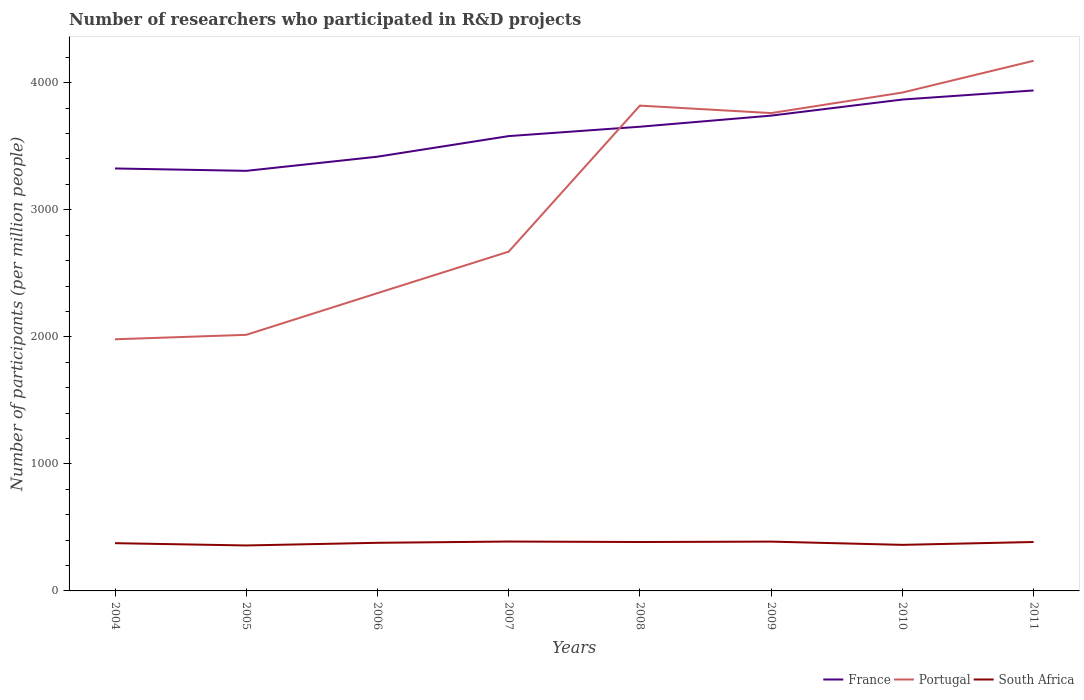Does the line corresponding to South Africa intersect with the line corresponding to France?
Make the answer very short. No. Is the number of lines equal to the number of legend labels?
Offer a terse response. Yes. Across all years, what is the maximum number of researchers who participated in R&D projects in South Africa?
Provide a succinct answer. 357.85. In which year was the number of researchers who participated in R&D projects in Portugal maximum?
Your response must be concise. 2004. What is the total number of researchers who participated in R&D projects in South Africa in the graph?
Provide a succinct answer. -9.97. What is the difference between the highest and the second highest number of researchers who participated in R&D projects in South Africa?
Your answer should be very brief. 30.94. What is the difference between the highest and the lowest number of researchers who participated in R&D projects in South Africa?
Provide a succinct answer. 5. How many lines are there?
Make the answer very short. 3. What is the difference between two consecutive major ticks on the Y-axis?
Offer a very short reply. 1000. Are the values on the major ticks of Y-axis written in scientific E-notation?
Provide a succinct answer. No. Does the graph contain any zero values?
Your answer should be very brief. No. Does the graph contain grids?
Your response must be concise. No. Where does the legend appear in the graph?
Make the answer very short. Bottom right. How are the legend labels stacked?
Ensure brevity in your answer.  Horizontal. What is the title of the graph?
Your response must be concise. Number of researchers who participated in R&D projects. What is the label or title of the X-axis?
Offer a terse response. Years. What is the label or title of the Y-axis?
Ensure brevity in your answer.  Number of participants (per million people). What is the Number of participants (per million people) in France in 2004?
Give a very brief answer. 3325.36. What is the Number of participants (per million people) of Portugal in 2004?
Offer a very short reply. 1980.77. What is the Number of participants (per million people) of South Africa in 2004?
Your answer should be compact. 375.83. What is the Number of participants (per million people) in France in 2005?
Provide a succinct answer. 3306.68. What is the Number of participants (per million people) of Portugal in 2005?
Provide a succinct answer. 2015.85. What is the Number of participants (per million people) in South Africa in 2005?
Make the answer very short. 357.85. What is the Number of participants (per million people) of France in 2006?
Ensure brevity in your answer.  3418.13. What is the Number of participants (per million people) of Portugal in 2006?
Your answer should be compact. 2344.02. What is the Number of participants (per million people) in South Africa in 2006?
Provide a short and direct response. 378.82. What is the Number of participants (per million people) of France in 2007?
Provide a succinct answer. 3580.19. What is the Number of participants (per million people) of Portugal in 2007?
Offer a terse response. 2670.52. What is the Number of participants (per million people) of South Africa in 2007?
Keep it short and to the point. 388.79. What is the Number of participants (per million people) of France in 2008?
Ensure brevity in your answer.  3653.99. What is the Number of participants (per million people) in Portugal in 2008?
Make the answer very short. 3820.2. What is the Number of participants (per million people) in South Africa in 2008?
Give a very brief answer. 385. What is the Number of participants (per million people) in France in 2009?
Provide a succinct answer. 3741.42. What is the Number of participants (per million people) in Portugal in 2009?
Provide a succinct answer. 3761.39. What is the Number of participants (per million people) in South Africa in 2009?
Offer a very short reply. 388.16. What is the Number of participants (per million people) in France in 2010?
Your answer should be compact. 3867.99. What is the Number of participants (per million people) of Portugal in 2010?
Your answer should be compact. 3922.91. What is the Number of participants (per million people) in South Africa in 2010?
Your response must be concise. 362.63. What is the Number of participants (per million people) in France in 2011?
Offer a very short reply. 3939.51. What is the Number of participants (per million people) of Portugal in 2011?
Keep it short and to the point. 4172.86. What is the Number of participants (per million people) of South Africa in 2011?
Offer a terse response. 385.07. Across all years, what is the maximum Number of participants (per million people) in France?
Keep it short and to the point. 3939.51. Across all years, what is the maximum Number of participants (per million people) of Portugal?
Your answer should be very brief. 4172.86. Across all years, what is the maximum Number of participants (per million people) in South Africa?
Make the answer very short. 388.79. Across all years, what is the minimum Number of participants (per million people) of France?
Offer a terse response. 3306.68. Across all years, what is the minimum Number of participants (per million people) of Portugal?
Give a very brief answer. 1980.77. Across all years, what is the minimum Number of participants (per million people) in South Africa?
Your answer should be very brief. 357.85. What is the total Number of participants (per million people) in France in the graph?
Make the answer very short. 2.88e+04. What is the total Number of participants (per million people) in Portugal in the graph?
Make the answer very short. 2.47e+04. What is the total Number of participants (per million people) of South Africa in the graph?
Provide a short and direct response. 3022.14. What is the difference between the Number of participants (per million people) of France in 2004 and that in 2005?
Your answer should be compact. 18.68. What is the difference between the Number of participants (per million people) of Portugal in 2004 and that in 2005?
Provide a short and direct response. -35.07. What is the difference between the Number of participants (per million people) of South Africa in 2004 and that in 2005?
Your answer should be compact. 17.98. What is the difference between the Number of participants (per million people) of France in 2004 and that in 2006?
Ensure brevity in your answer.  -92.77. What is the difference between the Number of participants (per million people) in Portugal in 2004 and that in 2006?
Keep it short and to the point. -363.25. What is the difference between the Number of participants (per million people) of South Africa in 2004 and that in 2006?
Provide a short and direct response. -3. What is the difference between the Number of participants (per million people) in France in 2004 and that in 2007?
Offer a very short reply. -254.83. What is the difference between the Number of participants (per million people) of Portugal in 2004 and that in 2007?
Make the answer very short. -689.75. What is the difference between the Number of participants (per million people) in South Africa in 2004 and that in 2007?
Your response must be concise. -12.96. What is the difference between the Number of participants (per million people) of France in 2004 and that in 2008?
Offer a very short reply. -328.63. What is the difference between the Number of participants (per million people) of Portugal in 2004 and that in 2008?
Provide a succinct answer. -1839.42. What is the difference between the Number of participants (per million people) in South Africa in 2004 and that in 2008?
Offer a very short reply. -9.18. What is the difference between the Number of participants (per million people) in France in 2004 and that in 2009?
Offer a terse response. -416.06. What is the difference between the Number of participants (per million people) of Portugal in 2004 and that in 2009?
Your answer should be compact. -1780.62. What is the difference between the Number of participants (per million people) of South Africa in 2004 and that in 2009?
Offer a very short reply. -12.33. What is the difference between the Number of participants (per million people) of France in 2004 and that in 2010?
Your answer should be very brief. -542.63. What is the difference between the Number of participants (per million people) in Portugal in 2004 and that in 2010?
Make the answer very short. -1942.14. What is the difference between the Number of participants (per million people) of South Africa in 2004 and that in 2010?
Make the answer very short. 13.19. What is the difference between the Number of participants (per million people) of France in 2004 and that in 2011?
Give a very brief answer. -614.15. What is the difference between the Number of participants (per million people) in Portugal in 2004 and that in 2011?
Give a very brief answer. -2192.09. What is the difference between the Number of participants (per million people) of South Africa in 2004 and that in 2011?
Give a very brief answer. -9.25. What is the difference between the Number of participants (per million people) in France in 2005 and that in 2006?
Keep it short and to the point. -111.45. What is the difference between the Number of participants (per million people) in Portugal in 2005 and that in 2006?
Your answer should be very brief. -328.18. What is the difference between the Number of participants (per million people) of South Africa in 2005 and that in 2006?
Keep it short and to the point. -20.97. What is the difference between the Number of participants (per million people) of France in 2005 and that in 2007?
Ensure brevity in your answer.  -273.51. What is the difference between the Number of participants (per million people) in Portugal in 2005 and that in 2007?
Provide a short and direct response. -654.68. What is the difference between the Number of participants (per million people) of South Africa in 2005 and that in 2007?
Give a very brief answer. -30.94. What is the difference between the Number of participants (per million people) of France in 2005 and that in 2008?
Provide a short and direct response. -347.31. What is the difference between the Number of participants (per million people) in Portugal in 2005 and that in 2008?
Make the answer very short. -1804.35. What is the difference between the Number of participants (per million people) of South Africa in 2005 and that in 2008?
Give a very brief answer. -27.15. What is the difference between the Number of participants (per million people) of France in 2005 and that in 2009?
Keep it short and to the point. -434.74. What is the difference between the Number of participants (per million people) of Portugal in 2005 and that in 2009?
Ensure brevity in your answer.  -1745.55. What is the difference between the Number of participants (per million people) in South Africa in 2005 and that in 2009?
Provide a succinct answer. -30.31. What is the difference between the Number of participants (per million people) in France in 2005 and that in 2010?
Ensure brevity in your answer.  -561.31. What is the difference between the Number of participants (per million people) of Portugal in 2005 and that in 2010?
Provide a succinct answer. -1907.07. What is the difference between the Number of participants (per million people) in South Africa in 2005 and that in 2010?
Make the answer very short. -4.78. What is the difference between the Number of participants (per million people) of France in 2005 and that in 2011?
Provide a succinct answer. -632.83. What is the difference between the Number of participants (per million people) of Portugal in 2005 and that in 2011?
Ensure brevity in your answer.  -2157.02. What is the difference between the Number of participants (per million people) in South Africa in 2005 and that in 2011?
Offer a very short reply. -27.22. What is the difference between the Number of participants (per million people) of France in 2006 and that in 2007?
Make the answer very short. -162.06. What is the difference between the Number of participants (per million people) of Portugal in 2006 and that in 2007?
Your response must be concise. -326.5. What is the difference between the Number of participants (per million people) in South Africa in 2006 and that in 2007?
Make the answer very short. -9.97. What is the difference between the Number of participants (per million people) of France in 2006 and that in 2008?
Provide a succinct answer. -235.86. What is the difference between the Number of participants (per million people) of Portugal in 2006 and that in 2008?
Ensure brevity in your answer.  -1476.17. What is the difference between the Number of participants (per million people) of South Africa in 2006 and that in 2008?
Give a very brief answer. -6.18. What is the difference between the Number of participants (per million people) in France in 2006 and that in 2009?
Your answer should be very brief. -323.29. What is the difference between the Number of participants (per million people) of Portugal in 2006 and that in 2009?
Ensure brevity in your answer.  -1417.37. What is the difference between the Number of participants (per million people) in South Africa in 2006 and that in 2009?
Your answer should be compact. -9.34. What is the difference between the Number of participants (per million people) of France in 2006 and that in 2010?
Make the answer very short. -449.86. What is the difference between the Number of participants (per million people) of Portugal in 2006 and that in 2010?
Your answer should be very brief. -1578.89. What is the difference between the Number of participants (per million people) in South Africa in 2006 and that in 2010?
Your answer should be very brief. 16.19. What is the difference between the Number of participants (per million people) of France in 2006 and that in 2011?
Offer a terse response. -521.38. What is the difference between the Number of participants (per million people) of Portugal in 2006 and that in 2011?
Offer a terse response. -1828.84. What is the difference between the Number of participants (per million people) in South Africa in 2006 and that in 2011?
Your answer should be compact. -6.25. What is the difference between the Number of participants (per million people) in France in 2007 and that in 2008?
Offer a very short reply. -73.8. What is the difference between the Number of participants (per million people) in Portugal in 2007 and that in 2008?
Offer a terse response. -1149.67. What is the difference between the Number of participants (per million people) of South Africa in 2007 and that in 2008?
Make the answer very short. 3.79. What is the difference between the Number of participants (per million people) of France in 2007 and that in 2009?
Make the answer very short. -161.23. What is the difference between the Number of participants (per million people) in Portugal in 2007 and that in 2009?
Ensure brevity in your answer.  -1090.87. What is the difference between the Number of participants (per million people) in South Africa in 2007 and that in 2009?
Give a very brief answer. 0.63. What is the difference between the Number of participants (per million people) in France in 2007 and that in 2010?
Your answer should be very brief. -287.8. What is the difference between the Number of participants (per million people) of Portugal in 2007 and that in 2010?
Keep it short and to the point. -1252.39. What is the difference between the Number of participants (per million people) of South Africa in 2007 and that in 2010?
Offer a very short reply. 26.16. What is the difference between the Number of participants (per million people) of France in 2007 and that in 2011?
Ensure brevity in your answer.  -359.32. What is the difference between the Number of participants (per million people) of Portugal in 2007 and that in 2011?
Your response must be concise. -1502.34. What is the difference between the Number of participants (per million people) of South Africa in 2007 and that in 2011?
Give a very brief answer. 3.72. What is the difference between the Number of participants (per million people) in France in 2008 and that in 2009?
Keep it short and to the point. -87.43. What is the difference between the Number of participants (per million people) in Portugal in 2008 and that in 2009?
Give a very brief answer. 58.8. What is the difference between the Number of participants (per million people) in South Africa in 2008 and that in 2009?
Make the answer very short. -3.16. What is the difference between the Number of participants (per million people) in France in 2008 and that in 2010?
Keep it short and to the point. -214. What is the difference between the Number of participants (per million people) of Portugal in 2008 and that in 2010?
Your response must be concise. -102.72. What is the difference between the Number of participants (per million people) in South Africa in 2008 and that in 2010?
Make the answer very short. 22.37. What is the difference between the Number of participants (per million people) of France in 2008 and that in 2011?
Your answer should be compact. -285.52. What is the difference between the Number of participants (per million people) of Portugal in 2008 and that in 2011?
Your answer should be very brief. -352.67. What is the difference between the Number of participants (per million people) in South Africa in 2008 and that in 2011?
Provide a succinct answer. -0.07. What is the difference between the Number of participants (per million people) of France in 2009 and that in 2010?
Provide a short and direct response. -126.57. What is the difference between the Number of participants (per million people) of Portugal in 2009 and that in 2010?
Your answer should be very brief. -161.52. What is the difference between the Number of participants (per million people) in South Africa in 2009 and that in 2010?
Offer a terse response. 25.53. What is the difference between the Number of participants (per million people) in France in 2009 and that in 2011?
Give a very brief answer. -198.09. What is the difference between the Number of participants (per million people) in Portugal in 2009 and that in 2011?
Offer a terse response. -411.47. What is the difference between the Number of participants (per million people) in South Africa in 2009 and that in 2011?
Provide a succinct answer. 3.09. What is the difference between the Number of participants (per million people) of France in 2010 and that in 2011?
Offer a terse response. -71.52. What is the difference between the Number of participants (per million people) in Portugal in 2010 and that in 2011?
Keep it short and to the point. -249.95. What is the difference between the Number of participants (per million people) in South Africa in 2010 and that in 2011?
Give a very brief answer. -22.44. What is the difference between the Number of participants (per million people) of France in 2004 and the Number of participants (per million people) of Portugal in 2005?
Provide a succinct answer. 1309.52. What is the difference between the Number of participants (per million people) in France in 2004 and the Number of participants (per million people) in South Africa in 2005?
Provide a short and direct response. 2967.52. What is the difference between the Number of participants (per million people) in Portugal in 2004 and the Number of participants (per million people) in South Africa in 2005?
Offer a very short reply. 1622.93. What is the difference between the Number of participants (per million people) in France in 2004 and the Number of participants (per million people) in Portugal in 2006?
Offer a terse response. 981.34. What is the difference between the Number of participants (per million people) of France in 2004 and the Number of participants (per million people) of South Africa in 2006?
Provide a succinct answer. 2946.54. What is the difference between the Number of participants (per million people) of Portugal in 2004 and the Number of participants (per million people) of South Africa in 2006?
Your answer should be very brief. 1601.95. What is the difference between the Number of participants (per million people) of France in 2004 and the Number of participants (per million people) of Portugal in 2007?
Keep it short and to the point. 654.84. What is the difference between the Number of participants (per million people) in France in 2004 and the Number of participants (per million people) in South Africa in 2007?
Provide a succinct answer. 2936.58. What is the difference between the Number of participants (per million people) of Portugal in 2004 and the Number of participants (per million people) of South Africa in 2007?
Make the answer very short. 1591.99. What is the difference between the Number of participants (per million people) of France in 2004 and the Number of participants (per million people) of Portugal in 2008?
Your answer should be very brief. -494.83. What is the difference between the Number of participants (per million people) in France in 2004 and the Number of participants (per million people) in South Africa in 2008?
Make the answer very short. 2940.36. What is the difference between the Number of participants (per million people) of Portugal in 2004 and the Number of participants (per million people) of South Africa in 2008?
Provide a short and direct response. 1595.77. What is the difference between the Number of participants (per million people) in France in 2004 and the Number of participants (per million people) in Portugal in 2009?
Keep it short and to the point. -436.03. What is the difference between the Number of participants (per million people) in France in 2004 and the Number of participants (per million people) in South Africa in 2009?
Keep it short and to the point. 2937.2. What is the difference between the Number of participants (per million people) of Portugal in 2004 and the Number of participants (per million people) of South Africa in 2009?
Offer a very short reply. 1592.61. What is the difference between the Number of participants (per million people) of France in 2004 and the Number of participants (per million people) of Portugal in 2010?
Provide a succinct answer. -597.55. What is the difference between the Number of participants (per million people) in France in 2004 and the Number of participants (per million people) in South Africa in 2010?
Provide a short and direct response. 2962.73. What is the difference between the Number of participants (per million people) of Portugal in 2004 and the Number of participants (per million people) of South Africa in 2010?
Make the answer very short. 1618.14. What is the difference between the Number of participants (per million people) in France in 2004 and the Number of participants (per million people) in Portugal in 2011?
Provide a short and direct response. -847.5. What is the difference between the Number of participants (per million people) in France in 2004 and the Number of participants (per million people) in South Africa in 2011?
Ensure brevity in your answer.  2940.29. What is the difference between the Number of participants (per million people) of Portugal in 2004 and the Number of participants (per million people) of South Africa in 2011?
Provide a short and direct response. 1595.7. What is the difference between the Number of participants (per million people) in France in 2005 and the Number of participants (per million people) in Portugal in 2006?
Offer a terse response. 962.66. What is the difference between the Number of participants (per million people) of France in 2005 and the Number of participants (per million people) of South Africa in 2006?
Your answer should be very brief. 2927.86. What is the difference between the Number of participants (per million people) of Portugal in 2005 and the Number of participants (per million people) of South Africa in 2006?
Offer a terse response. 1637.03. What is the difference between the Number of participants (per million people) of France in 2005 and the Number of participants (per million people) of Portugal in 2007?
Your response must be concise. 636.16. What is the difference between the Number of participants (per million people) of France in 2005 and the Number of participants (per million people) of South Africa in 2007?
Offer a very short reply. 2917.89. What is the difference between the Number of participants (per million people) of Portugal in 2005 and the Number of participants (per million people) of South Africa in 2007?
Offer a terse response. 1627.06. What is the difference between the Number of participants (per million people) in France in 2005 and the Number of participants (per million people) in Portugal in 2008?
Provide a succinct answer. -513.51. What is the difference between the Number of participants (per million people) of France in 2005 and the Number of participants (per million people) of South Africa in 2008?
Ensure brevity in your answer.  2921.68. What is the difference between the Number of participants (per million people) in Portugal in 2005 and the Number of participants (per million people) in South Africa in 2008?
Provide a short and direct response. 1630.85. What is the difference between the Number of participants (per million people) of France in 2005 and the Number of participants (per million people) of Portugal in 2009?
Give a very brief answer. -454.71. What is the difference between the Number of participants (per million people) in France in 2005 and the Number of participants (per million people) in South Africa in 2009?
Give a very brief answer. 2918.52. What is the difference between the Number of participants (per million people) in Portugal in 2005 and the Number of participants (per million people) in South Africa in 2009?
Make the answer very short. 1627.69. What is the difference between the Number of participants (per million people) of France in 2005 and the Number of participants (per million people) of Portugal in 2010?
Give a very brief answer. -616.23. What is the difference between the Number of participants (per million people) of France in 2005 and the Number of participants (per million people) of South Africa in 2010?
Keep it short and to the point. 2944.05. What is the difference between the Number of participants (per million people) of Portugal in 2005 and the Number of participants (per million people) of South Africa in 2010?
Your response must be concise. 1653.22. What is the difference between the Number of participants (per million people) of France in 2005 and the Number of participants (per million people) of Portugal in 2011?
Offer a terse response. -866.18. What is the difference between the Number of participants (per million people) in France in 2005 and the Number of participants (per million people) in South Africa in 2011?
Offer a terse response. 2921.61. What is the difference between the Number of participants (per million people) of Portugal in 2005 and the Number of participants (per million people) of South Africa in 2011?
Provide a succinct answer. 1630.78. What is the difference between the Number of participants (per million people) in France in 2006 and the Number of participants (per million people) in Portugal in 2007?
Keep it short and to the point. 747.61. What is the difference between the Number of participants (per million people) in France in 2006 and the Number of participants (per million people) in South Africa in 2007?
Make the answer very short. 3029.34. What is the difference between the Number of participants (per million people) of Portugal in 2006 and the Number of participants (per million people) of South Africa in 2007?
Make the answer very short. 1955.24. What is the difference between the Number of participants (per million people) in France in 2006 and the Number of participants (per million people) in Portugal in 2008?
Provide a short and direct response. -402.06. What is the difference between the Number of participants (per million people) in France in 2006 and the Number of participants (per million people) in South Africa in 2008?
Your answer should be compact. 3033.13. What is the difference between the Number of participants (per million people) of Portugal in 2006 and the Number of participants (per million people) of South Africa in 2008?
Offer a terse response. 1959.02. What is the difference between the Number of participants (per million people) in France in 2006 and the Number of participants (per million people) in Portugal in 2009?
Give a very brief answer. -343.26. What is the difference between the Number of participants (per million people) in France in 2006 and the Number of participants (per million people) in South Africa in 2009?
Your answer should be very brief. 3029.97. What is the difference between the Number of participants (per million people) of Portugal in 2006 and the Number of participants (per million people) of South Africa in 2009?
Ensure brevity in your answer.  1955.86. What is the difference between the Number of participants (per million people) in France in 2006 and the Number of participants (per million people) in Portugal in 2010?
Make the answer very short. -504.78. What is the difference between the Number of participants (per million people) of France in 2006 and the Number of participants (per million people) of South Africa in 2010?
Your response must be concise. 3055.5. What is the difference between the Number of participants (per million people) in Portugal in 2006 and the Number of participants (per million people) in South Africa in 2010?
Offer a terse response. 1981.39. What is the difference between the Number of participants (per million people) in France in 2006 and the Number of participants (per million people) in Portugal in 2011?
Your answer should be compact. -754.73. What is the difference between the Number of participants (per million people) of France in 2006 and the Number of participants (per million people) of South Africa in 2011?
Provide a short and direct response. 3033.06. What is the difference between the Number of participants (per million people) in Portugal in 2006 and the Number of participants (per million people) in South Africa in 2011?
Your response must be concise. 1958.95. What is the difference between the Number of participants (per million people) of France in 2007 and the Number of participants (per million people) of Portugal in 2008?
Your response must be concise. -240. What is the difference between the Number of participants (per million people) in France in 2007 and the Number of participants (per million people) in South Africa in 2008?
Offer a very short reply. 3195.19. What is the difference between the Number of participants (per million people) of Portugal in 2007 and the Number of participants (per million people) of South Africa in 2008?
Provide a short and direct response. 2285.52. What is the difference between the Number of participants (per million people) of France in 2007 and the Number of participants (per million people) of Portugal in 2009?
Provide a succinct answer. -181.2. What is the difference between the Number of participants (per million people) in France in 2007 and the Number of participants (per million people) in South Africa in 2009?
Provide a succinct answer. 3192.03. What is the difference between the Number of participants (per million people) in Portugal in 2007 and the Number of participants (per million people) in South Africa in 2009?
Offer a terse response. 2282.36. What is the difference between the Number of participants (per million people) of France in 2007 and the Number of participants (per million people) of Portugal in 2010?
Offer a terse response. -342.72. What is the difference between the Number of participants (per million people) in France in 2007 and the Number of participants (per million people) in South Africa in 2010?
Give a very brief answer. 3217.56. What is the difference between the Number of participants (per million people) in Portugal in 2007 and the Number of participants (per million people) in South Africa in 2010?
Keep it short and to the point. 2307.89. What is the difference between the Number of participants (per million people) in France in 2007 and the Number of participants (per million people) in Portugal in 2011?
Your answer should be compact. -592.67. What is the difference between the Number of participants (per million people) in France in 2007 and the Number of participants (per million people) in South Africa in 2011?
Your answer should be very brief. 3195.12. What is the difference between the Number of participants (per million people) of Portugal in 2007 and the Number of participants (per million people) of South Africa in 2011?
Give a very brief answer. 2285.45. What is the difference between the Number of participants (per million people) in France in 2008 and the Number of participants (per million people) in Portugal in 2009?
Offer a very short reply. -107.4. What is the difference between the Number of participants (per million people) of France in 2008 and the Number of participants (per million people) of South Africa in 2009?
Your response must be concise. 3265.83. What is the difference between the Number of participants (per million people) of Portugal in 2008 and the Number of participants (per million people) of South Africa in 2009?
Your response must be concise. 3432.04. What is the difference between the Number of participants (per million people) of France in 2008 and the Number of participants (per million people) of Portugal in 2010?
Your answer should be compact. -268.92. What is the difference between the Number of participants (per million people) in France in 2008 and the Number of participants (per million people) in South Africa in 2010?
Provide a succinct answer. 3291.36. What is the difference between the Number of participants (per million people) in Portugal in 2008 and the Number of participants (per million people) in South Africa in 2010?
Keep it short and to the point. 3457.56. What is the difference between the Number of participants (per million people) of France in 2008 and the Number of participants (per million people) of Portugal in 2011?
Ensure brevity in your answer.  -518.87. What is the difference between the Number of participants (per million people) in France in 2008 and the Number of participants (per million people) in South Africa in 2011?
Make the answer very short. 3268.92. What is the difference between the Number of participants (per million people) in Portugal in 2008 and the Number of participants (per million people) in South Africa in 2011?
Provide a succinct answer. 3435.12. What is the difference between the Number of participants (per million people) of France in 2009 and the Number of participants (per million people) of Portugal in 2010?
Provide a succinct answer. -181.49. What is the difference between the Number of participants (per million people) in France in 2009 and the Number of participants (per million people) in South Africa in 2010?
Make the answer very short. 3378.79. What is the difference between the Number of participants (per million people) in Portugal in 2009 and the Number of participants (per million people) in South Africa in 2010?
Your response must be concise. 3398.76. What is the difference between the Number of participants (per million people) of France in 2009 and the Number of participants (per million people) of Portugal in 2011?
Offer a terse response. -431.44. What is the difference between the Number of participants (per million people) in France in 2009 and the Number of participants (per million people) in South Africa in 2011?
Your answer should be compact. 3356.35. What is the difference between the Number of participants (per million people) in Portugal in 2009 and the Number of participants (per million people) in South Africa in 2011?
Your response must be concise. 3376.32. What is the difference between the Number of participants (per million people) in France in 2010 and the Number of participants (per million people) in Portugal in 2011?
Offer a terse response. -304.87. What is the difference between the Number of participants (per million people) of France in 2010 and the Number of participants (per million people) of South Africa in 2011?
Ensure brevity in your answer.  3482.92. What is the difference between the Number of participants (per million people) of Portugal in 2010 and the Number of participants (per million people) of South Africa in 2011?
Provide a short and direct response. 3537.84. What is the average Number of participants (per million people) in France per year?
Provide a succinct answer. 3604.16. What is the average Number of participants (per million people) in Portugal per year?
Make the answer very short. 3086.07. What is the average Number of participants (per million people) in South Africa per year?
Your answer should be compact. 377.77. In the year 2004, what is the difference between the Number of participants (per million people) in France and Number of participants (per million people) in Portugal?
Your answer should be compact. 1344.59. In the year 2004, what is the difference between the Number of participants (per million people) in France and Number of participants (per million people) in South Africa?
Provide a succinct answer. 2949.54. In the year 2004, what is the difference between the Number of participants (per million people) in Portugal and Number of participants (per million people) in South Africa?
Your answer should be compact. 1604.95. In the year 2005, what is the difference between the Number of participants (per million people) of France and Number of participants (per million people) of Portugal?
Keep it short and to the point. 1290.83. In the year 2005, what is the difference between the Number of participants (per million people) of France and Number of participants (per million people) of South Africa?
Give a very brief answer. 2948.83. In the year 2005, what is the difference between the Number of participants (per million people) in Portugal and Number of participants (per million people) in South Africa?
Your answer should be very brief. 1658. In the year 2006, what is the difference between the Number of participants (per million people) in France and Number of participants (per million people) in Portugal?
Provide a short and direct response. 1074.11. In the year 2006, what is the difference between the Number of participants (per million people) in France and Number of participants (per million people) in South Africa?
Your answer should be compact. 3039.31. In the year 2006, what is the difference between the Number of participants (per million people) in Portugal and Number of participants (per million people) in South Africa?
Provide a short and direct response. 1965.2. In the year 2007, what is the difference between the Number of participants (per million people) in France and Number of participants (per million people) in Portugal?
Provide a succinct answer. 909.67. In the year 2007, what is the difference between the Number of participants (per million people) in France and Number of participants (per million people) in South Africa?
Your answer should be very brief. 3191.41. In the year 2007, what is the difference between the Number of participants (per million people) in Portugal and Number of participants (per million people) in South Africa?
Offer a very short reply. 2281.74. In the year 2008, what is the difference between the Number of participants (per million people) in France and Number of participants (per million people) in Portugal?
Ensure brevity in your answer.  -166.2. In the year 2008, what is the difference between the Number of participants (per million people) of France and Number of participants (per million people) of South Africa?
Keep it short and to the point. 3268.99. In the year 2008, what is the difference between the Number of participants (per million people) in Portugal and Number of participants (per million people) in South Africa?
Provide a short and direct response. 3435.19. In the year 2009, what is the difference between the Number of participants (per million people) in France and Number of participants (per million people) in Portugal?
Provide a succinct answer. -19.97. In the year 2009, what is the difference between the Number of participants (per million people) of France and Number of participants (per million people) of South Africa?
Provide a short and direct response. 3353.26. In the year 2009, what is the difference between the Number of participants (per million people) of Portugal and Number of participants (per million people) of South Africa?
Offer a terse response. 3373.23. In the year 2010, what is the difference between the Number of participants (per million people) of France and Number of participants (per million people) of Portugal?
Your response must be concise. -54.92. In the year 2010, what is the difference between the Number of participants (per million people) in France and Number of participants (per million people) in South Africa?
Offer a terse response. 3505.36. In the year 2010, what is the difference between the Number of participants (per million people) of Portugal and Number of participants (per million people) of South Africa?
Keep it short and to the point. 3560.28. In the year 2011, what is the difference between the Number of participants (per million people) in France and Number of participants (per million people) in Portugal?
Make the answer very short. -233.35. In the year 2011, what is the difference between the Number of participants (per million people) of France and Number of participants (per million people) of South Africa?
Keep it short and to the point. 3554.44. In the year 2011, what is the difference between the Number of participants (per million people) in Portugal and Number of participants (per million people) in South Africa?
Ensure brevity in your answer.  3787.79. What is the ratio of the Number of participants (per million people) of France in 2004 to that in 2005?
Give a very brief answer. 1.01. What is the ratio of the Number of participants (per million people) of Portugal in 2004 to that in 2005?
Provide a short and direct response. 0.98. What is the ratio of the Number of participants (per million people) in South Africa in 2004 to that in 2005?
Keep it short and to the point. 1.05. What is the ratio of the Number of participants (per million people) of France in 2004 to that in 2006?
Your response must be concise. 0.97. What is the ratio of the Number of participants (per million people) of Portugal in 2004 to that in 2006?
Keep it short and to the point. 0.84. What is the ratio of the Number of participants (per million people) of South Africa in 2004 to that in 2006?
Give a very brief answer. 0.99. What is the ratio of the Number of participants (per million people) in France in 2004 to that in 2007?
Give a very brief answer. 0.93. What is the ratio of the Number of participants (per million people) in Portugal in 2004 to that in 2007?
Provide a short and direct response. 0.74. What is the ratio of the Number of participants (per million people) of South Africa in 2004 to that in 2007?
Make the answer very short. 0.97. What is the ratio of the Number of participants (per million people) of France in 2004 to that in 2008?
Make the answer very short. 0.91. What is the ratio of the Number of participants (per million people) of Portugal in 2004 to that in 2008?
Provide a short and direct response. 0.52. What is the ratio of the Number of participants (per million people) of South Africa in 2004 to that in 2008?
Provide a succinct answer. 0.98. What is the ratio of the Number of participants (per million people) in France in 2004 to that in 2009?
Your response must be concise. 0.89. What is the ratio of the Number of participants (per million people) in Portugal in 2004 to that in 2009?
Your response must be concise. 0.53. What is the ratio of the Number of participants (per million people) in South Africa in 2004 to that in 2009?
Keep it short and to the point. 0.97. What is the ratio of the Number of participants (per million people) in France in 2004 to that in 2010?
Provide a short and direct response. 0.86. What is the ratio of the Number of participants (per million people) in Portugal in 2004 to that in 2010?
Your answer should be very brief. 0.5. What is the ratio of the Number of participants (per million people) in South Africa in 2004 to that in 2010?
Ensure brevity in your answer.  1.04. What is the ratio of the Number of participants (per million people) of France in 2004 to that in 2011?
Provide a short and direct response. 0.84. What is the ratio of the Number of participants (per million people) of Portugal in 2004 to that in 2011?
Your answer should be very brief. 0.47. What is the ratio of the Number of participants (per million people) in France in 2005 to that in 2006?
Offer a very short reply. 0.97. What is the ratio of the Number of participants (per million people) in Portugal in 2005 to that in 2006?
Your answer should be very brief. 0.86. What is the ratio of the Number of participants (per million people) in South Africa in 2005 to that in 2006?
Ensure brevity in your answer.  0.94. What is the ratio of the Number of participants (per million people) of France in 2005 to that in 2007?
Ensure brevity in your answer.  0.92. What is the ratio of the Number of participants (per million people) in Portugal in 2005 to that in 2007?
Your response must be concise. 0.75. What is the ratio of the Number of participants (per million people) in South Africa in 2005 to that in 2007?
Offer a terse response. 0.92. What is the ratio of the Number of participants (per million people) in France in 2005 to that in 2008?
Your answer should be compact. 0.91. What is the ratio of the Number of participants (per million people) in Portugal in 2005 to that in 2008?
Provide a succinct answer. 0.53. What is the ratio of the Number of participants (per million people) of South Africa in 2005 to that in 2008?
Your answer should be compact. 0.93. What is the ratio of the Number of participants (per million people) of France in 2005 to that in 2009?
Make the answer very short. 0.88. What is the ratio of the Number of participants (per million people) in Portugal in 2005 to that in 2009?
Offer a very short reply. 0.54. What is the ratio of the Number of participants (per million people) of South Africa in 2005 to that in 2009?
Your answer should be compact. 0.92. What is the ratio of the Number of participants (per million people) in France in 2005 to that in 2010?
Your answer should be very brief. 0.85. What is the ratio of the Number of participants (per million people) in Portugal in 2005 to that in 2010?
Provide a succinct answer. 0.51. What is the ratio of the Number of participants (per million people) in South Africa in 2005 to that in 2010?
Your answer should be compact. 0.99. What is the ratio of the Number of participants (per million people) in France in 2005 to that in 2011?
Give a very brief answer. 0.84. What is the ratio of the Number of participants (per million people) in Portugal in 2005 to that in 2011?
Offer a terse response. 0.48. What is the ratio of the Number of participants (per million people) in South Africa in 2005 to that in 2011?
Provide a short and direct response. 0.93. What is the ratio of the Number of participants (per million people) of France in 2006 to that in 2007?
Provide a short and direct response. 0.95. What is the ratio of the Number of participants (per million people) of Portugal in 2006 to that in 2007?
Provide a succinct answer. 0.88. What is the ratio of the Number of participants (per million people) in South Africa in 2006 to that in 2007?
Give a very brief answer. 0.97. What is the ratio of the Number of participants (per million people) in France in 2006 to that in 2008?
Offer a very short reply. 0.94. What is the ratio of the Number of participants (per million people) in Portugal in 2006 to that in 2008?
Your answer should be compact. 0.61. What is the ratio of the Number of participants (per million people) of South Africa in 2006 to that in 2008?
Provide a succinct answer. 0.98. What is the ratio of the Number of participants (per million people) of France in 2006 to that in 2009?
Ensure brevity in your answer.  0.91. What is the ratio of the Number of participants (per million people) of Portugal in 2006 to that in 2009?
Keep it short and to the point. 0.62. What is the ratio of the Number of participants (per million people) in South Africa in 2006 to that in 2009?
Your response must be concise. 0.98. What is the ratio of the Number of participants (per million people) of France in 2006 to that in 2010?
Your answer should be very brief. 0.88. What is the ratio of the Number of participants (per million people) in Portugal in 2006 to that in 2010?
Give a very brief answer. 0.6. What is the ratio of the Number of participants (per million people) in South Africa in 2006 to that in 2010?
Make the answer very short. 1.04. What is the ratio of the Number of participants (per million people) of France in 2006 to that in 2011?
Make the answer very short. 0.87. What is the ratio of the Number of participants (per million people) in Portugal in 2006 to that in 2011?
Keep it short and to the point. 0.56. What is the ratio of the Number of participants (per million people) of South Africa in 2006 to that in 2011?
Your answer should be compact. 0.98. What is the ratio of the Number of participants (per million people) in France in 2007 to that in 2008?
Give a very brief answer. 0.98. What is the ratio of the Number of participants (per million people) in Portugal in 2007 to that in 2008?
Your answer should be very brief. 0.7. What is the ratio of the Number of participants (per million people) in South Africa in 2007 to that in 2008?
Ensure brevity in your answer.  1.01. What is the ratio of the Number of participants (per million people) in France in 2007 to that in 2009?
Ensure brevity in your answer.  0.96. What is the ratio of the Number of participants (per million people) in Portugal in 2007 to that in 2009?
Keep it short and to the point. 0.71. What is the ratio of the Number of participants (per million people) of France in 2007 to that in 2010?
Offer a very short reply. 0.93. What is the ratio of the Number of participants (per million people) of Portugal in 2007 to that in 2010?
Provide a short and direct response. 0.68. What is the ratio of the Number of participants (per million people) of South Africa in 2007 to that in 2010?
Ensure brevity in your answer.  1.07. What is the ratio of the Number of participants (per million people) of France in 2007 to that in 2011?
Offer a very short reply. 0.91. What is the ratio of the Number of participants (per million people) in Portugal in 2007 to that in 2011?
Provide a short and direct response. 0.64. What is the ratio of the Number of participants (per million people) of South Africa in 2007 to that in 2011?
Make the answer very short. 1.01. What is the ratio of the Number of participants (per million people) in France in 2008 to that in 2009?
Your answer should be compact. 0.98. What is the ratio of the Number of participants (per million people) of Portugal in 2008 to that in 2009?
Keep it short and to the point. 1.02. What is the ratio of the Number of participants (per million people) in France in 2008 to that in 2010?
Offer a terse response. 0.94. What is the ratio of the Number of participants (per million people) of Portugal in 2008 to that in 2010?
Provide a succinct answer. 0.97. What is the ratio of the Number of participants (per million people) in South Africa in 2008 to that in 2010?
Your response must be concise. 1.06. What is the ratio of the Number of participants (per million people) in France in 2008 to that in 2011?
Keep it short and to the point. 0.93. What is the ratio of the Number of participants (per million people) of Portugal in 2008 to that in 2011?
Provide a short and direct response. 0.92. What is the ratio of the Number of participants (per million people) of South Africa in 2008 to that in 2011?
Make the answer very short. 1. What is the ratio of the Number of participants (per million people) in France in 2009 to that in 2010?
Your answer should be compact. 0.97. What is the ratio of the Number of participants (per million people) in Portugal in 2009 to that in 2010?
Offer a terse response. 0.96. What is the ratio of the Number of participants (per million people) in South Africa in 2009 to that in 2010?
Make the answer very short. 1.07. What is the ratio of the Number of participants (per million people) of France in 2009 to that in 2011?
Offer a terse response. 0.95. What is the ratio of the Number of participants (per million people) of Portugal in 2009 to that in 2011?
Your answer should be very brief. 0.9. What is the ratio of the Number of participants (per million people) in South Africa in 2009 to that in 2011?
Keep it short and to the point. 1.01. What is the ratio of the Number of participants (per million people) of France in 2010 to that in 2011?
Make the answer very short. 0.98. What is the ratio of the Number of participants (per million people) in Portugal in 2010 to that in 2011?
Provide a succinct answer. 0.94. What is the ratio of the Number of participants (per million people) in South Africa in 2010 to that in 2011?
Your response must be concise. 0.94. What is the difference between the highest and the second highest Number of participants (per million people) in France?
Offer a very short reply. 71.52. What is the difference between the highest and the second highest Number of participants (per million people) of Portugal?
Offer a terse response. 249.95. What is the difference between the highest and the second highest Number of participants (per million people) in South Africa?
Provide a short and direct response. 0.63. What is the difference between the highest and the lowest Number of participants (per million people) of France?
Offer a terse response. 632.83. What is the difference between the highest and the lowest Number of participants (per million people) of Portugal?
Your answer should be very brief. 2192.09. What is the difference between the highest and the lowest Number of participants (per million people) in South Africa?
Your answer should be very brief. 30.94. 